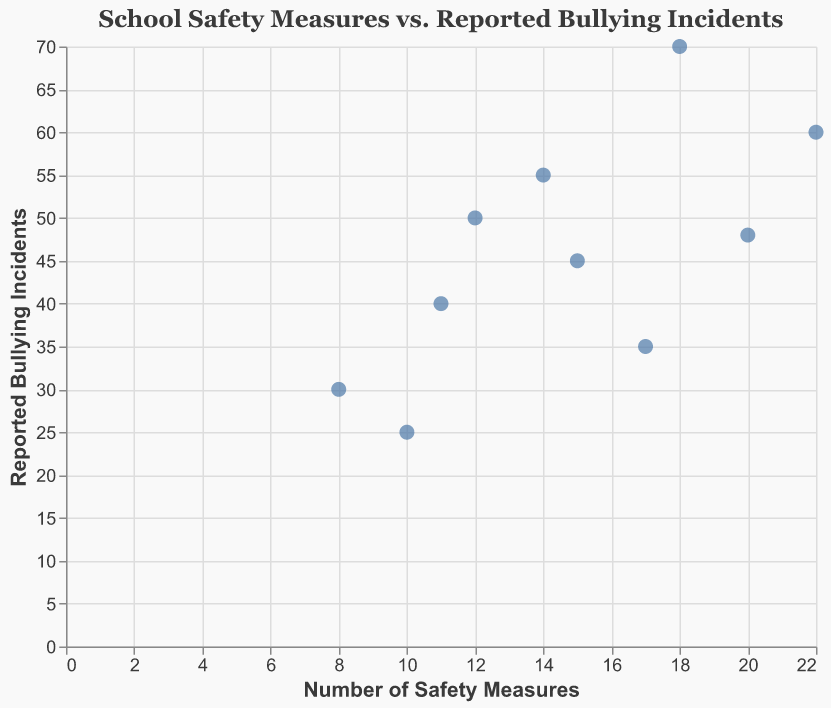What is the title of the figure? The title of the figure is located at the top and it describes the overall purpose or main subject of the figure.
Answer: School Safety Measures vs. Reported Bullying Incidents How many school districts are represented in the figure? Count the number of data points in the scatter plot, each representing a different school district.
Answer: 10 Which school district has the highest number of reported bullying incidents? Look for the data point that is highest on the y-axis, which represents the number of reported bullying incidents, and use the tooltip to identify the district.
Answer: New York City Which school district has the fewest safety measures in place? Look for the data point farthest to the left on the x-axis, which represents the number of safety measures, and use the tooltip to identify the district.
Answer: Dallas Independent School District What is the range of the number of safety measures across the school districts? Identify the minimum and maximum values on the x-axis to determine the range.
Answer: 8 to 22 How many reported bullying incidents does the Hillsborough County Public Schools have? Hover over the data point corresponding to Hillsborough County Public Schools to read the tooltip for the number of reported bullying incidents.
Answer: 35 Which district has more reported bullying incidents: Miami-Dade County or Broward County Public Schools? Compare the positions of the two districts on the y-axis and identify which is higher up.
Answer: Broward County Public Schools Calculate the average number of safety measures across all school districts. Sum the number of safety measures for all districts and divide by the total number of districts: (15+18+12+10+8+22+11+14+17+20) / 10 = 14.7
Answer: 14.7 Is there any apparent correlation between the number of safety measures and the reported bullying incidents? Observe the overall trend in the scatter plot. If points tend to follow a specific pattern (e.g., upward or downward), there may be a correlation.
Answer: No clear correlation Which district has both a high number of safety measures and a high number of reported bullying incidents? Look for data points that are high on both the x-axis and y-axis, and use the tooltip to identify the district.
Answer: New York City 